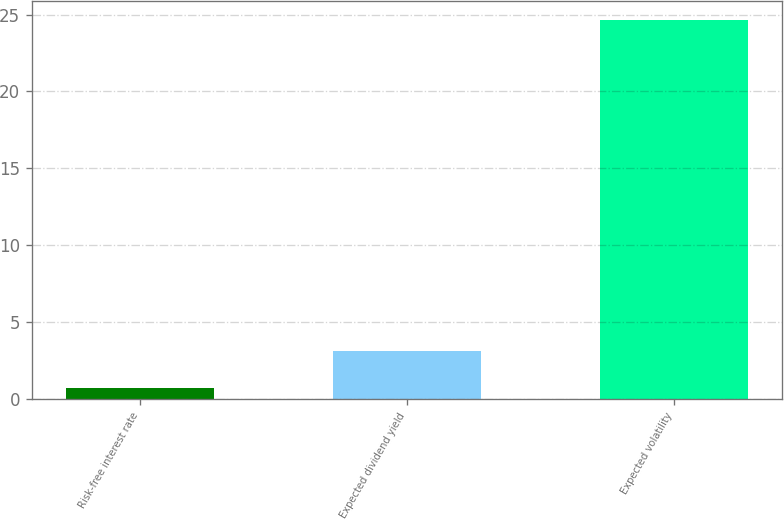Convert chart to OTSL. <chart><loc_0><loc_0><loc_500><loc_500><bar_chart><fcel>Risk-free interest rate<fcel>Expected dividend yield<fcel>Expected volatility<nl><fcel>0.75<fcel>3.14<fcel>24.65<nl></chart> 